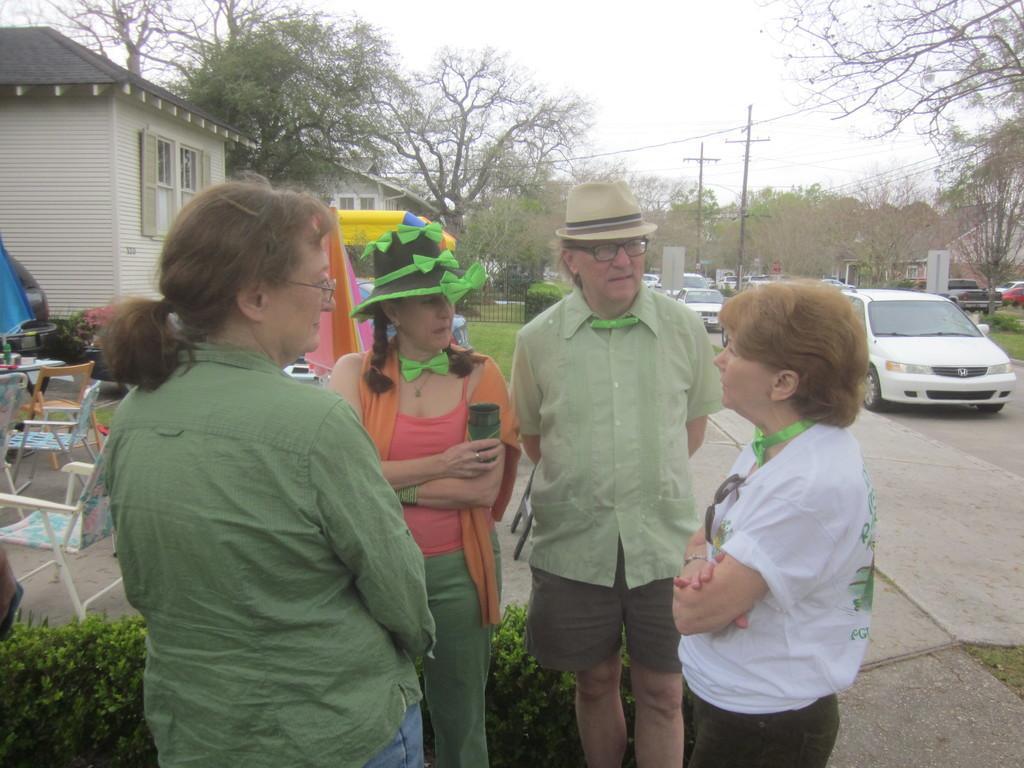Please provide a concise description of this image. In this image I can see 4 people standing. There are chairs, plants, buildings and fence. There are vehicles on the road and there are trees at the back. 